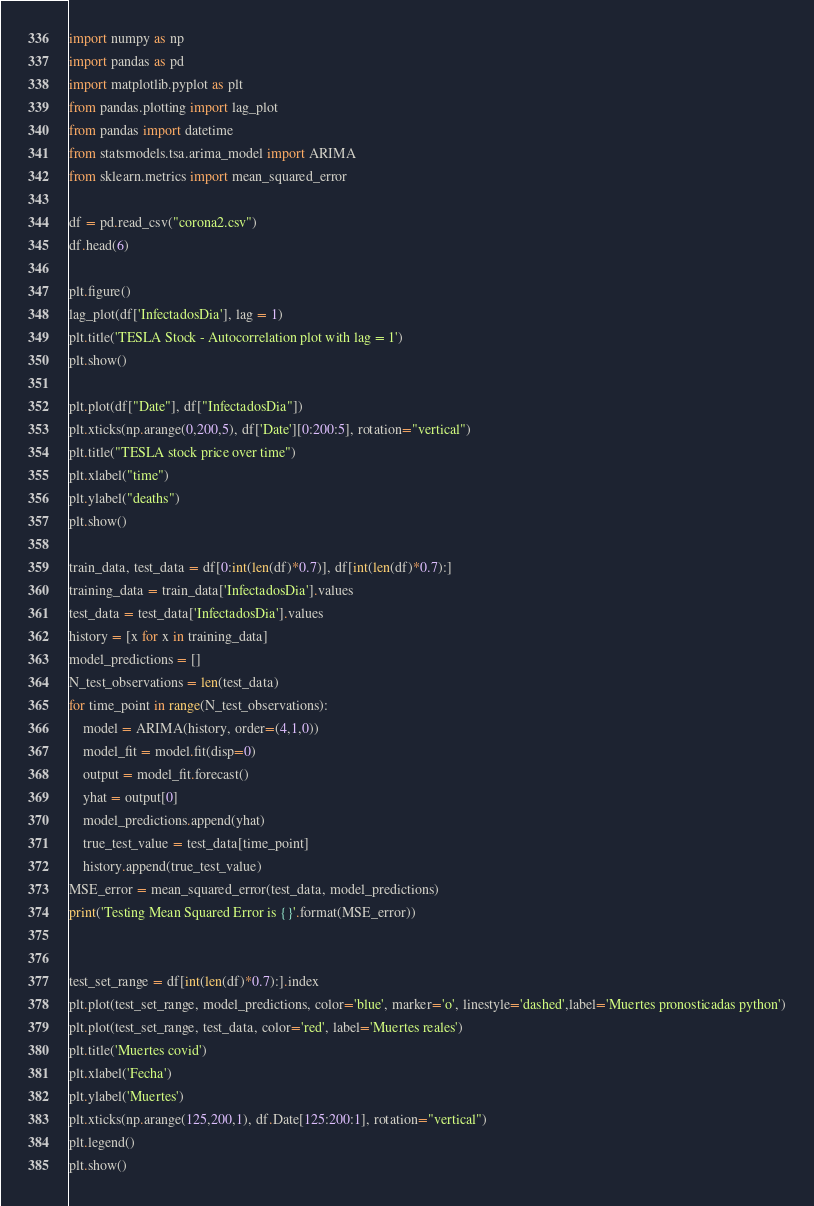Convert code to text. <code><loc_0><loc_0><loc_500><loc_500><_Python_>import numpy as np
import pandas as pd
import matplotlib.pyplot as plt
from pandas.plotting import lag_plot
from pandas import datetime
from statsmodels.tsa.arima_model import ARIMA
from sklearn.metrics import mean_squared_error

df = pd.read_csv("corona2.csv")
df.head(6)

plt.figure()
lag_plot(df['InfectadosDia'], lag = 1)
plt.title('TESLA Stock - Autocorrelation plot with lag = 1')
plt.show()

plt.plot(df["Date"], df["InfectadosDia"])
plt.xticks(np.arange(0,200,5), df['Date'][0:200:5], rotation="vertical")
plt.title("TESLA stock price over time")
plt.xlabel("time")
plt.ylabel("deaths")
plt.show()

train_data, test_data = df[0:int(len(df)*0.7)], df[int(len(df)*0.7):]
training_data = train_data['InfectadosDia'].values
test_data = test_data['InfectadosDia'].values
history = [x for x in training_data]
model_predictions = []
N_test_observations = len(test_data)
for time_point in range(N_test_observations):
    model = ARIMA(history, order=(4,1,0))
    model_fit = model.fit(disp=0)
    output = model_fit.forecast()
    yhat = output[0]
    model_predictions.append(yhat)
    true_test_value = test_data[time_point]
    history.append(true_test_value)
MSE_error = mean_squared_error(test_data, model_predictions)
print('Testing Mean Squared Error is {}'.format(MSE_error))


test_set_range = df[int(len(df)*0.7):].index
plt.plot(test_set_range, model_predictions, color='blue', marker='o', linestyle='dashed',label='Muertes pronosticadas python')
plt.plot(test_set_range, test_data, color='red', label='Muertes reales')
plt.title('Muertes covid')
plt.xlabel('Fecha')
plt.ylabel('Muertes')
plt.xticks(np.arange(125,200,1), df.Date[125:200:1], rotation="vertical")
plt.legend()
plt.show()
</code> 